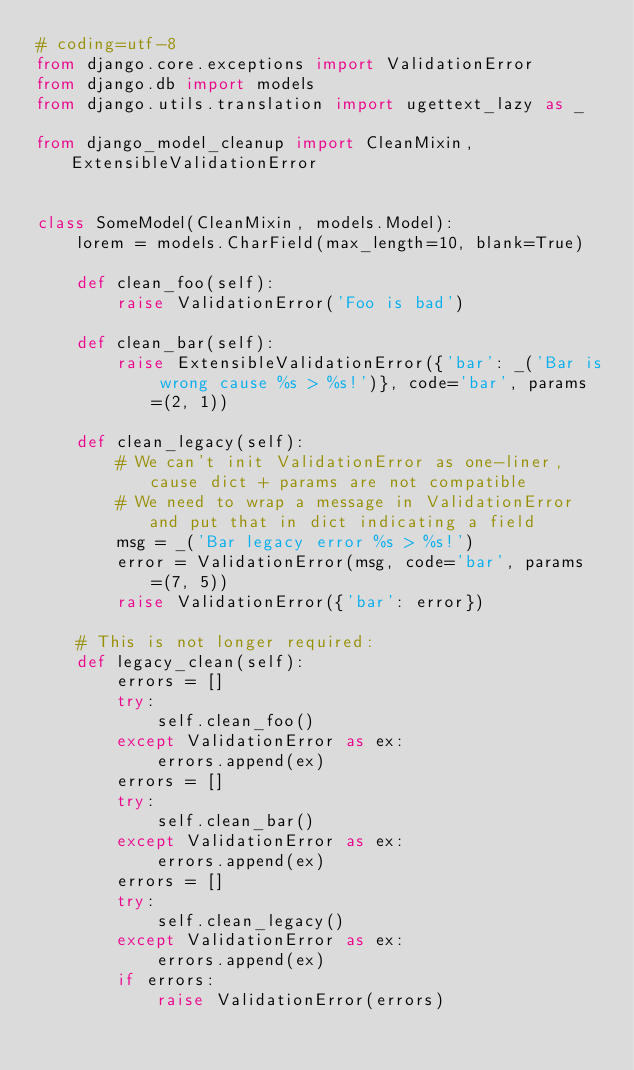<code> <loc_0><loc_0><loc_500><loc_500><_Python_># coding=utf-8
from django.core.exceptions import ValidationError
from django.db import models
from django.utils.translation import ugettext_lazy as _

from django_model_cleanup import CleanMixin, ExtensibleValidationError


class SomeModel(CleanMixin, models.Model):
    lorem = models.CharField(max_length=10, blank=True)

    def clean_foo(self):
        raise ValidationError('Foo is bad')

    def clean_bar(self):
        raise ExtensibleValidationError({'bar': _('Bar is wrong cause %s > %s!')}, code='bar', params=(2, 1))

    def clean_legacy(self):
        # We can't init ValidationError as one-liner, cause dict + params are not compatible
        # We need to wrap a message in ValidationError and put that in dict indicating a field
        msg = _('Bar legacy error %s > %s!')
        error = ValidationError(msg, code='bar', params=(7, 5))
        raise ValidationError({'bar': error})

    # This is not longer required:
    def legacy_clean(self):
        errors = []
        try:
            self.clean_foo()
        except ValidationError as ex:
            errors.append(ex)
        errors = []
        try:
            self.clean_bar()
        except ValidationError as ex:
            errors.append(ex)
        errors = []
        try:
            self.clean_legacy()
        except ValidationError as ex:
            errors.append(ex)
        if errors:
            raise ValidationError(errors)
</code> 